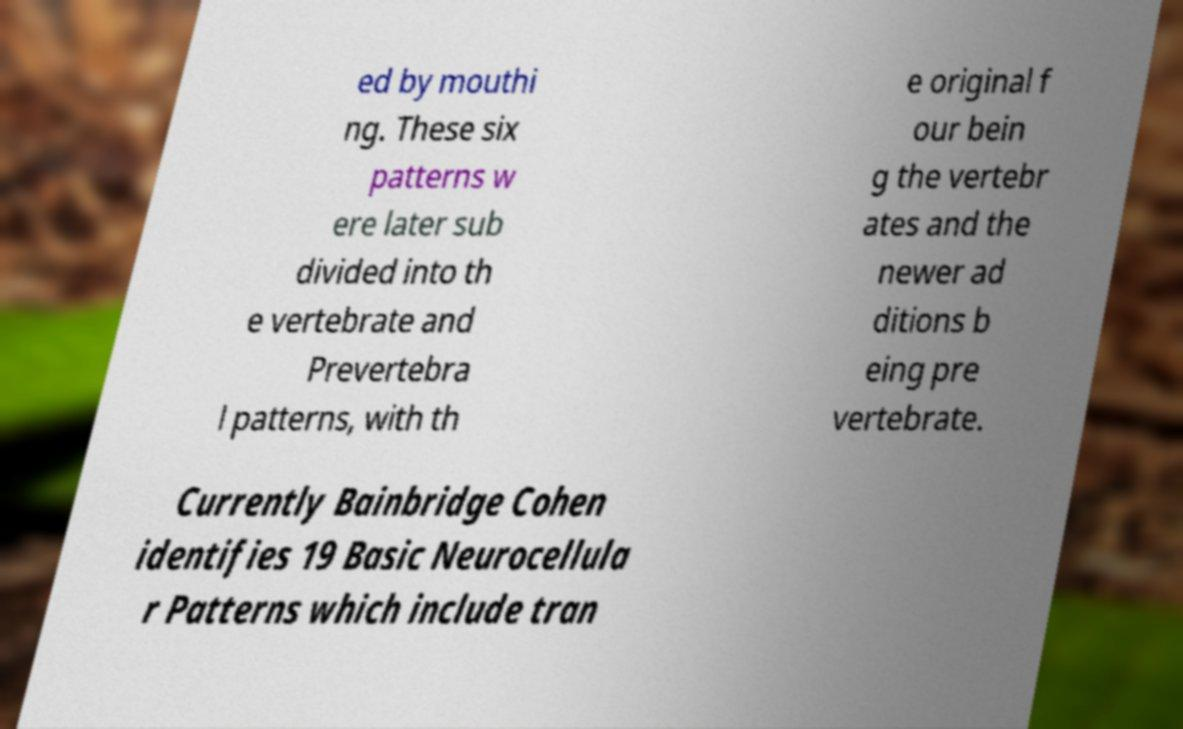Could you extract and type out the text from this image? ed by mouthi ng. These six patterns w ere later sub divided into th e vertebrate and Prevertebra l patterns, with th e original f our bein g the vertebr ates and the newer ad ditions b eing pre vertebrate. Currently Bainbridge Cohen identifies 19 Basic Neurocellula r Patterns which include tran 